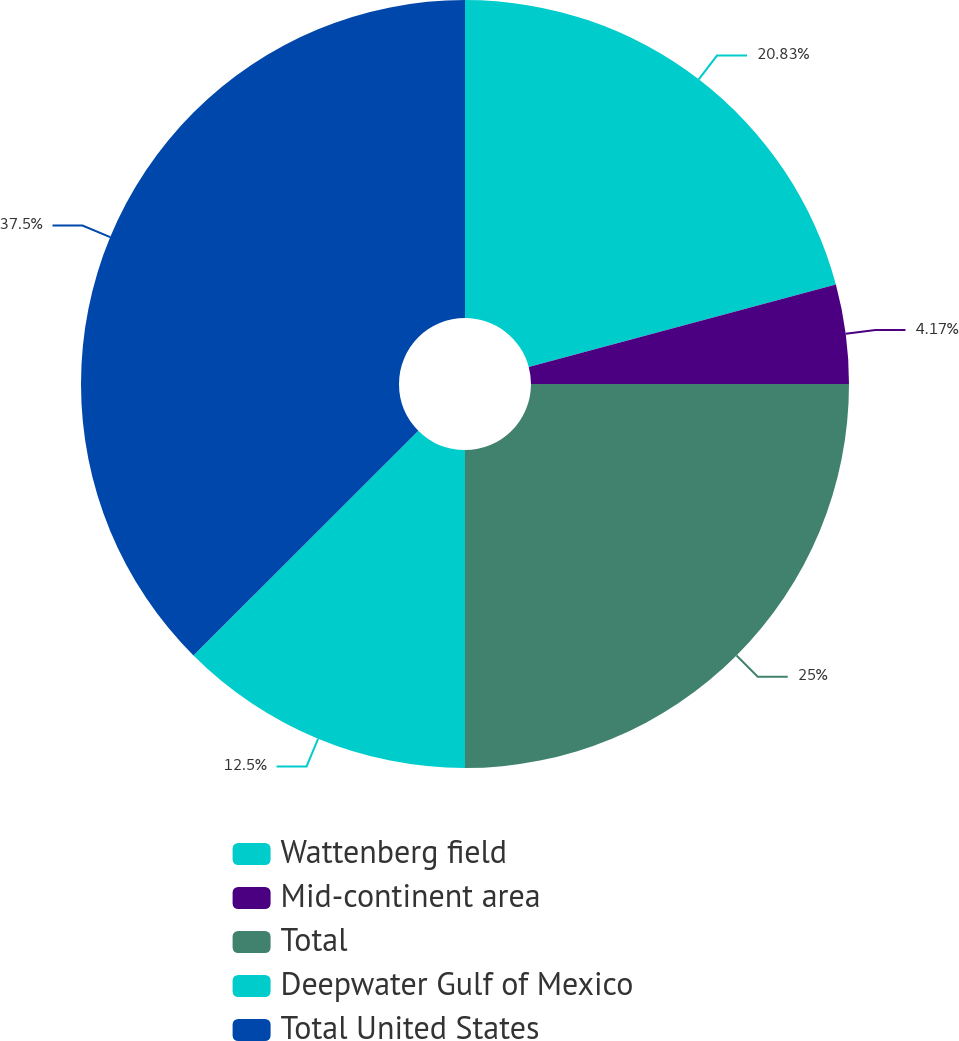<chart> <loc_0><loc_0><loc_500><loc_500><pie_chart><fcel>Wattenberg field<fcel>Mid-continent area<fcel>Total<fcel>Deepwater Gulf of Mexico<fcel>Total United States<nl><fcel>20.83%<fcel>4.17%<fcel>25.0%<fcel>12.5%<fcel>37.5%<nl></chart> 